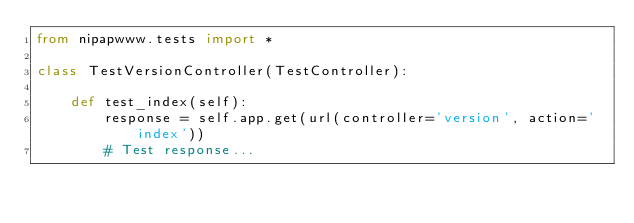Convert code to text. <code><loc_0><loc_0><loc_500><loc_500><_Python_>from nipapwww.tests import *

class TestVersionController(TestController):

    def test_index(self):
        response = self.app.get(url(controller='version', action='index'))
        # Test response...
</code> 